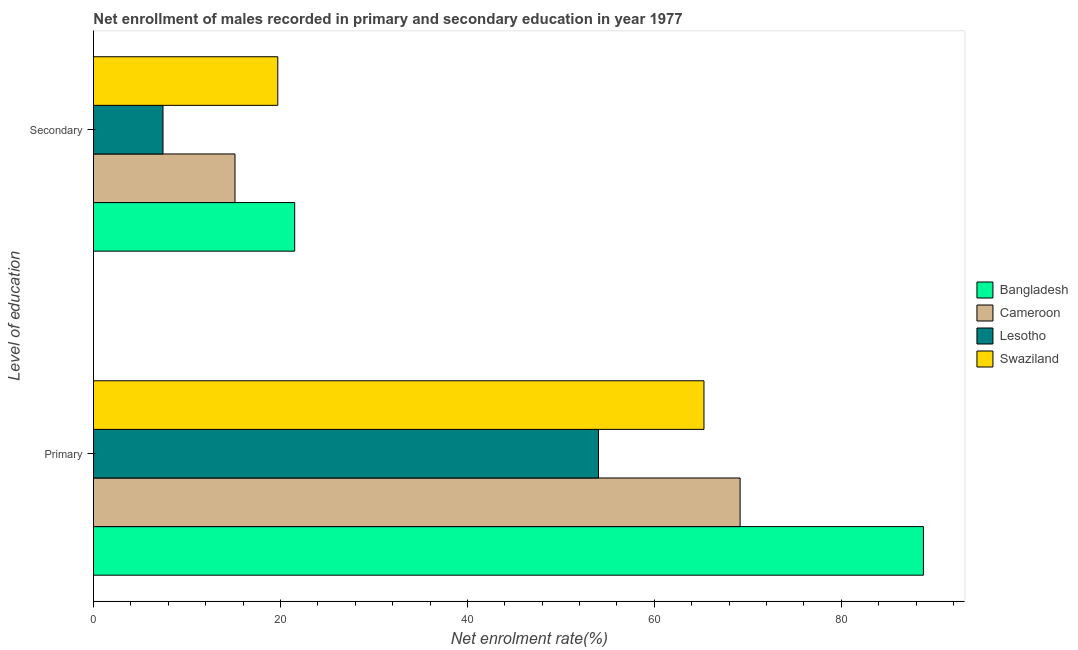How many groups of bars are there?
Your answer should be compact. 2. Are the number of bars per tick equal to the number of legend labels?
Offer a terse response. Yes. Are the number of bars on each tick of the Y-axis equal?
Your answer should be compact. Yes. What is the label of the 1st group of bars from the top?
Your answer should be compact. Secondary. What is the enrollment rate in primary education in Bangladesh?
Offer a very short reply. 88.78. Across all countries, what is the maximum enrollment rate in secondary education?
Keep it short and to the point. 21.52. Across all countries, what is the minimum enrollment rate in primary education?
Provide a short and direct response. 54.02. In which country was the enrollment rate in primary education minimum?
Make the answer very short. Lesotho. What is the total enrollment rate in primary education in the graph?
Keep it short and to the point. 277.28. What is the difference between the enrollment rate in primary education in Lesotho and that in Cameroon?
Provide a succinct answer. -15.15. What is the difference between the enrollment rate in primary education in Swaziland and the enrollment rate in secondary education in Cameroon?
Ensure brevity in your answer.  50.17. What is the average enrollment rate in primary education per country?
Your response must be concise. 69.32. What is the difference between the enrollment rate in primary education and enrollment rate in secondary education in Bangladesh?
Your response must be concise. 67.26. In how many countries, is the enrollment rate in primary education greater than 16 %?
Your response must be concise. 4. What is the ratio of the enrollment rate in secondary education in Cameroon to that in Swaziland?
Provide a short and direct response. 0.77. Is the enrollment rate in primary education in Bangladesh less than that in Swaziland?
Keep it short and to the point. No. In how many countries, is the enrollment rate in primary education greater than the average enrollment rate in primary education taken over all countries?
Provide a succinct answer. 1. What does the 4th bar from the top in Secondary represents?
Your response must be concise. Bangladesh. What does the 4th bar from the bottom in Secondary represents?
Make the answer very short. Swaziland. How many bars are there?
Provide a succinct answer. 8. Are all the bars in the graph horizontal?
Make the answer very short. Yes. How many countries are there in the graph?
Ensure brevity in your answer.  4. Are the values on the major ticks of X-axis written in scientific E-notation?
Provide a succinct answer. No. Does the graph contain grids?
Provide a short and direct response. No. How many legend labels are there?
Provide a short and direct response. 4. What is the title of the graph?
Offer a terse response. Net enrollment of males recorded in primary and secondary education in year 1977. What is the label or title of the X-axis?
Keep it short and to the point. Net enrolment rate(%). What is the label or title of the Y-axis?
Offer a terse response. Level of education. What is the Net enrolment rate(%) of Bangladesh in Primary?
Your answer should be very brief. 88.78. What is the Net enrolment rate(%) of Cameroon in Primary?
Your answer should be very brief. 69.17. What is the Net enrolment rate(%) of Lesotho in Primary?
Ensure brevity in your answer.  54.02. What is the Net enrolment rate(%) of Swaziland in Primary?
Ensure brevity in your answer.  65.31. What is the Net enrolment rate(%) in Bangladesh in Secondary?
Provide a succinct answer. 21.52. What is the Net enrolment rate(%) of Cameroon in Secondary?
Your answer should be compact. 15.14. What is the Net enrolment rate(%) of Lesotho in Secondary?
Offer a terse response. 7.44. What is the Net enrolment rate(%) of Swaziland in Secondary?
Your answer should be compact. 19.71. Across all Level of education, what is the maximum Net enrolment rate(%) of Bangladesh?
Provide a succinct answer. 88.78. Across all Level of education, what is the maximum Net enrolment rate(%) of Cameroon?
Keep it short and to the point. 69.17. Across all Level of education, what is the maximum Net enrolment rate(%) of Lesotho?
Your answer should be very brief. 54.02. Across all Level of education, what is the maximum Net enrolment rate(%) in Swaziland?
Offer a very short reply. 65.31. Across all Level of education, what is the minimum Net enrolment rate(%) in Bangladesh?
Give a very brief answer. 21.52. Across all Level of education, what is the minimum Net enrolment rate(%) of Cameroon?
Your response must be concise. 15.14. Across all Level of education, what is the minimum Net enrolment rate(%) in Lesotho?
Your answer should be compact. 7.44. Across all Level of education, what is the minimum Net enrolment rate(%) in Swaziland?
Ensure brevity in your answer.  19.71. What is the total Net enrolment rate(%) in Bangladesh in the graph?
Provide a succinct answer. 110.3. What is the total Net enrolment rate(%) in Cameroon in the graph?
Your answer should be very brief. 84.31. What is the total Net enrolment rate(%) in Lesotho in the graph?
Make the answer very short. 61.46. What is the total Net enrolment rate(%) in Swaziland in the graph?
Give a very brief answer. 85.02. What is the difference between the Net enrolment rate(%) in Bangladesh in Primary and that in Secondary?
Keep it short and to the point. 67.26. What is the difference between the Net enrolment rate(%) in Cameroon in Primary and that in Secondary?
Offer a terse response. 54.03. What is the difference between the Net enrolment rate(%) of Lesotho in Primary and that in Secondary?
Offer a terse response. 46.59. What is the difference between the Net enrolment rate(%) of Swaziland in Primary and that in Secondary?
Ensure brevity in your answer.  45.59. What is the difference between the Net enrolment rate(%) of Bangladesh in Primary and the Net enrolment rate(%) of Cameroon in Secondary?
Your answer should be compact. 73.64. What is the difference between the Net enrolment rate(%) of Bangladesh in Primary and the Net enrolment rate(%) of Lesotho in Secondary?
Give a very brief answer. 81.34. What is the difference between the Net enrolment rate(%) in Bangladesh in Primary and the Net enrolment rate(%) in Swaziland in Secondary?
Keep it short and to the point. 69.07. What is the difference between the Net enrolment rate(%) of Cameroon in Primary and the Net enrolment rate(%) of Lesotho in Secondary?
Your answer should be compact. 61.73. What is the difference between the Net enrolment rate(%) of Cameroon in Primary and the Net enrolment rate(%) of Swaziland in Secondary?
Offer a very short reply. 49.46. What is the difference between the Net enrolment rate(%) of Lesotho in Primary and the Net enrolment rate(%) of Swaziland in Secondary?
Make the answer very short. 34.31. What is the average Net enrolment rate(%) in Bangladesh per Level of education?
Provide a succinct answer. 55.15. What is the average Net enrolment rate(%) of Cameroon per Level of education?
Offer a very short reply. 42.15. What is the average Net enrolment rate(%) in Lesotho per Level of education?
Your answer should be compact. 30.73. What is the average Net enrolment rate(%) of Swaziland per Level of education?
Your answer should be very brief. 42.51. What is the difference between the Net enrolment rate(%) in Bangladesh and Net enrolment rate(%) in Cameroon in Primary?
Keep it short and to the point. 19.61. What is the difference between the Net enrolment rate(%) in Bangladesh and Net enrolment rate(%) in Lesotho in Primary?
Provide a short and direct response. 34.76. What is the difference between the Net enrolment rate(%) of Bangladesh and Net enrolment rate(%) of Swaziland in Primary?
Offer a terse response. 23.48. What is the difference between the Net enrolment rate(%) in Cameroon and Net enrolment rate(%) in Lesotho in Primary?
Make the answer very short. 15.15. What is the difference between the Net enrolment rate(%) of Cameroon and Net enrolment rate(%) of Swaziland in Primary?
Your response must be concise. 3.87. What is the difference between the Net enrolment rate(%) of Lesotho and Net enrolment rate(%) of Swaziland in Primary?
Provide a short and direct response. -11.28. What is the difference between the Net enrolment rate(%) in Bangladesh and Net enrolment rate(%) in Cameroon in Secondary?
Provide a short and direct response. 6.39. What is the difference between the Net enrolment rate(%) in Bangladesh and Net enrolment rate(%) in Lesotho in Secondary?
Keep it short and to the point. 14.09. What is the difference between the Net enrolment rate(%) of Bangladesh and Net enrolment rate(%) of Swaziland in Secondary?
Provide a short and direct response. 1.81. What is the difference between the Net enrolment rate(%) of Cameroon and Net enrolment rate(%) of Lesotho in Secondary?
Provide a succinct answer. 7.7. What is the difference between the Net enrolment rate(%) of Cameroon and Net enrolment rate(%) of Swaziland in Secondary?
Offer a terse response. -4.58. What is the difference between the Net enrolment rate(%) in Lesotho and Net enrolment rate(%) in Swaziland in Secondary?
Provide a short and direct response. -12.28. What is the ratio of the Net enrolment rate(%) of Bangladesh in Primary to that in Secondary?
Provide a succinct answer. 4.12. What is the ratio of the Net enrolment rate(%) in Cameroon in Primary to that in Secondary?
Your response must be concise. 4.57. What is the ratio of the Net enrolment rate(%) in Lesotho in Primary to that in Secondary?
Make the answer very short. 7.26. What is the ratio of the Net enrolment rate(%) in Swaziland in Primary to that in Secondary?
Offer a terse response. 3.31. What is the difference between the highest and the second highest Net enrolment rate(%) of Bangladesh?
Ensure brevity in your answer.  67.26. What is the difference between the highest and the second highest Net enrolment rate(%) in Cameroon?
Your answer should be very brief. 54.03. What is the difference between the highest and the second highest Net enrolment rate(%) in Lesotho?
Make the answer very short. 46.59. What is the difference between the highest and the second highest Net enrolment rate(%) in Swaziland?
Provide a succinct answer. 45.59. What is the difference between the highest and the lowest Net enrolment rate(%) of Bangladesh?
Make the answer very short. 67.26. What is the difference between the highest and the lowest Net enrolment rate(%) in Cameroon?
Give a very brief answer. 54.03. What is the difference between the highest and the lowest Net enrolment rate(%) in Lesotho?
Ensure brevity in your answer.  46.59. What is the difference between the highest and the lowest Net enrolment rate(%) in Swaziland?
Your response must be concise. 45.59. 